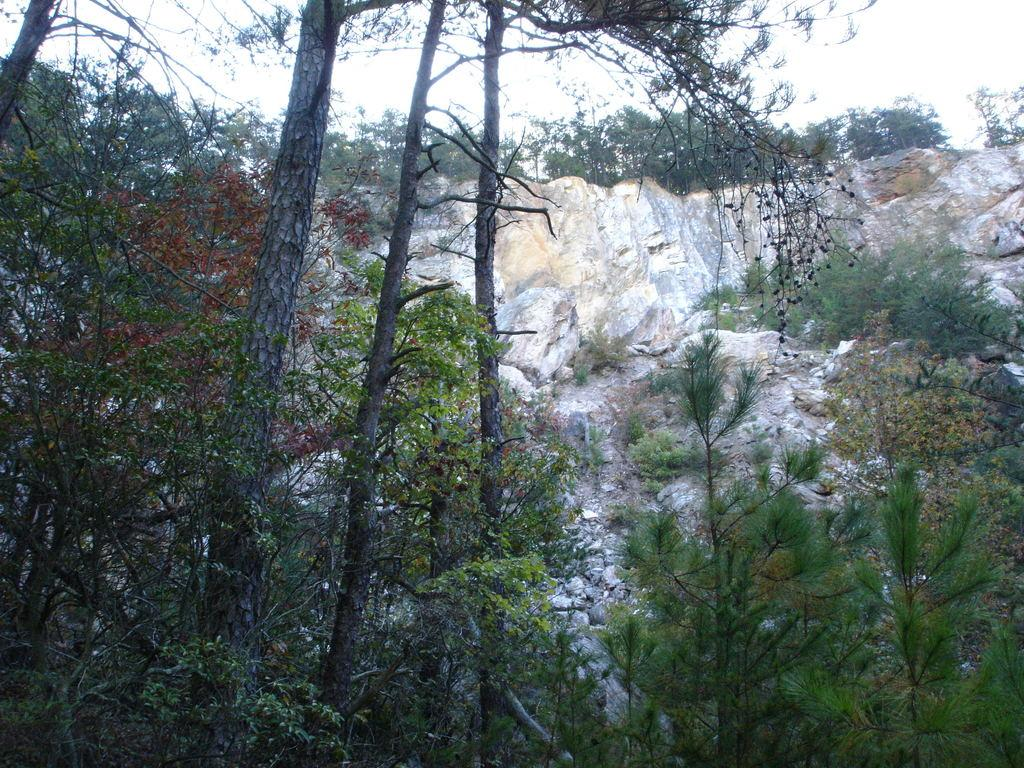What type of vegetation can be seen on both sides of the image? There are trees on both the right and left sides of the image. What is located in the center of the image? There are rocks in the center of the image. Can you see a couple kissing on a bed in the image? There is no couple or bed present in the image; it features trees and rocks. How many screws are visible in the image? There are no screws visible in the image. 